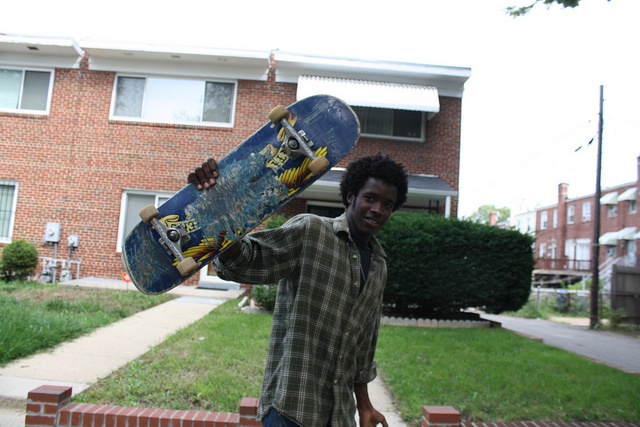Describe the objects in this image and their specific colors. I can see people in white, black, and gray tones and skateboard in white, blue, gray, black, and navy tones in this image. 